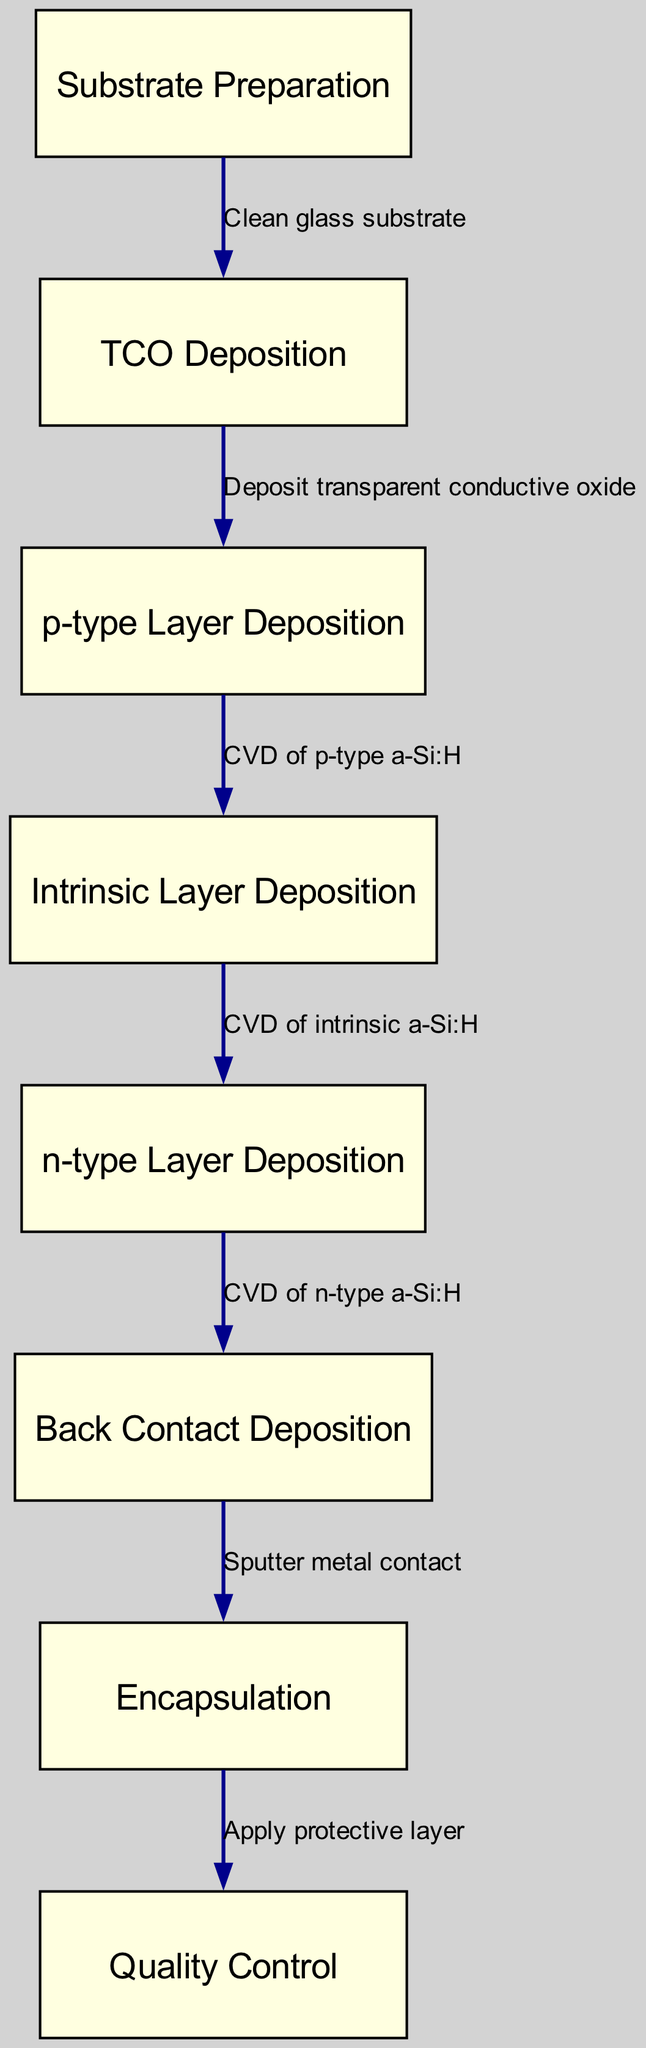What is the first step in the manufacturing process? The diagram shows that the "Substrate Preparation" is the first node in the flowchart. This indicates that it is the initial step in the thin-film solar cell manufacturing process.
Answer: Substrate Preparation How many nodes are present in the diagram? By counting the entries listed under the "nodes" section in the diagram data, we find there are eight distinct nodes representing different steps in the manufacturing process.
Answer: Eight What does the edge between "TCO Deposition" and "p-type Layer Deposition" represent? The label on the edge indicates the process that occurs between these two nodes, which is "Deposit transparent conductive oxide." This represents the action taken after TCO deposition.
Answer: Deposit transparent conductive oxide Which layer is deposited after the intrinsic layer? The flow of the diagram suggests that the next step, or node, after "Intrinsic Layer Deposition" is "n-type Layer Deposition." Therefore, this is the layer that is deposited consecutively after the intrinsic layer.
Answer: n-type Layer Deposition What is the last step indicated in the manufacturing process? The last node in the flowchart is "Quality Control," which shows that it is the final step after the encapsulation stage, and it ensures the final product meets quality standards.
Answer: Quality Control Which two steps are directly connected without any intermediate layers? From the diagram's flow, "Back Contact Deposition" directly leads to "Encapsulation," indicating that these two steps are connected sequentially without any other layers in between.
Answer: Back Contact Deposition and Encapsulation What type of layer is deposited third in the manufacturing process? By following the sequential steps outlined in the diagram, after "p-type Layer Deposition" and "Intrinsic Layer Deposition," the third type of layer deposited is "n-type Layer Deposition."
Answer: n-type Layer Deposition What is applied as the protective layer in the final step? According to the last edge leading from "Encapsulation," it indicates that a "protective layer" is applied, which is a critical step in ensuring reliability and durability of the solar cells.
Answer: Protective layer 